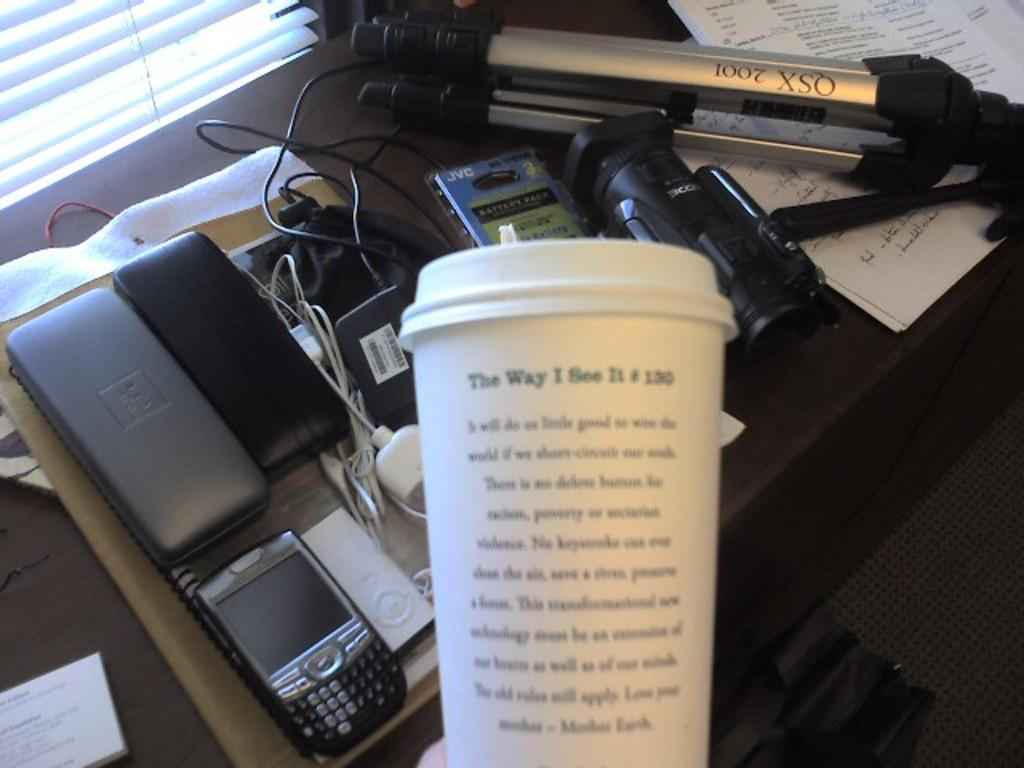What is the main piece of furniture in the image? There is a table in the image. What electronic device is on the table? There is a camera on the table. What type of items can be seen on the table besides the camera? There are papers, a mobile, cables, and devices on the table. What is located near the table in the image? There is a bag in the image. What type of flooring is visible in the image? There is a carpet on the floor. What type of poisonous substance is stored in the jar on the table? There is no jar present on the table in the image. What type of beans are visible in the image? There are no beans visible in the image. 